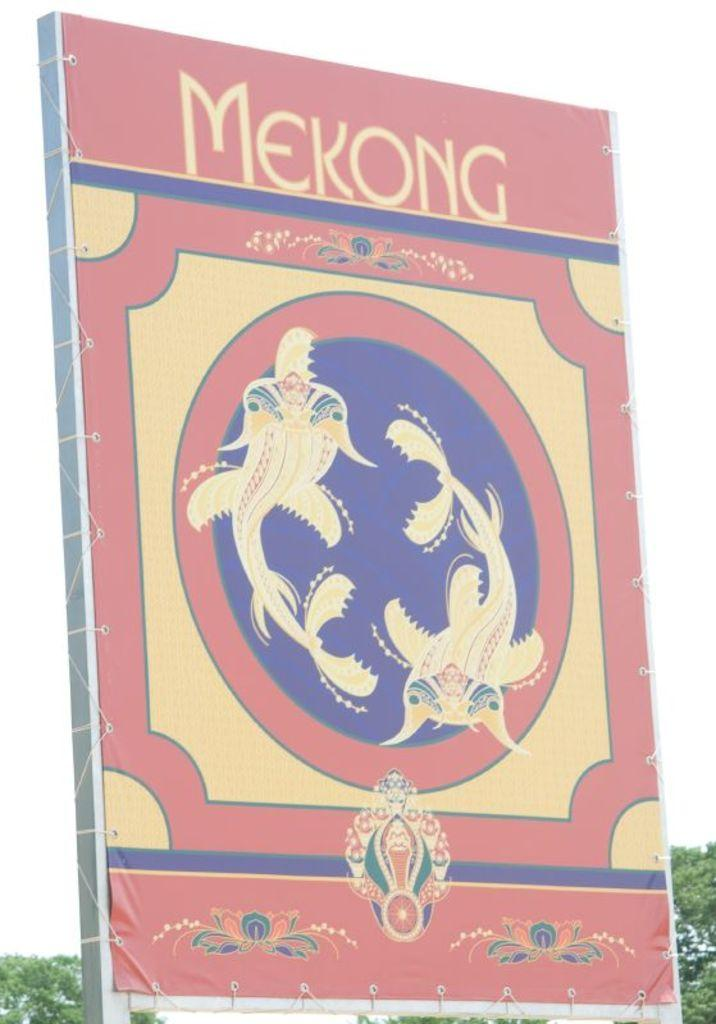<image>
Present a compact description of the photo's key features. A sign outside of a business in pale blue, yellow, and red and has the word Mekong on it 